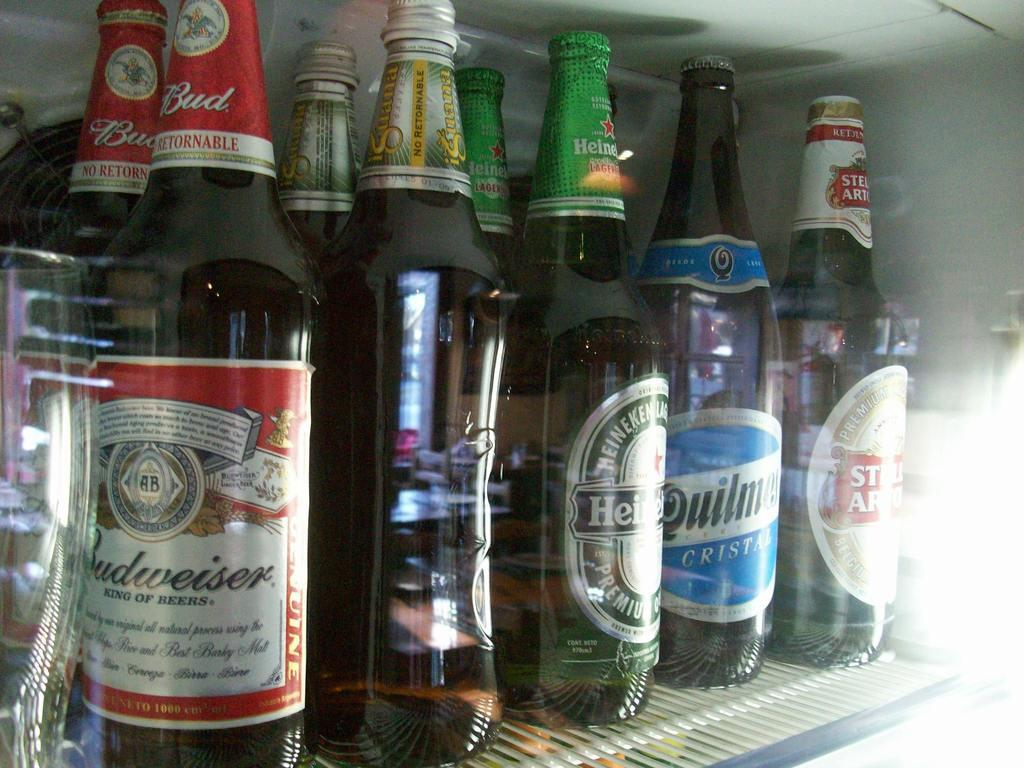<image>
Share a concise interpretation of the image provided. Bottle of beer including Budweiser and Stella Artois 